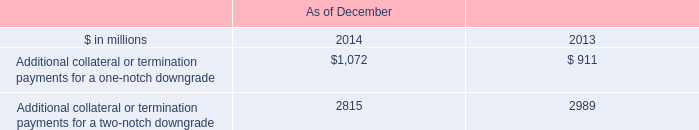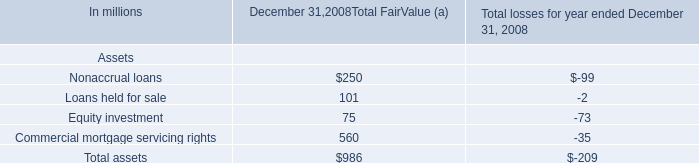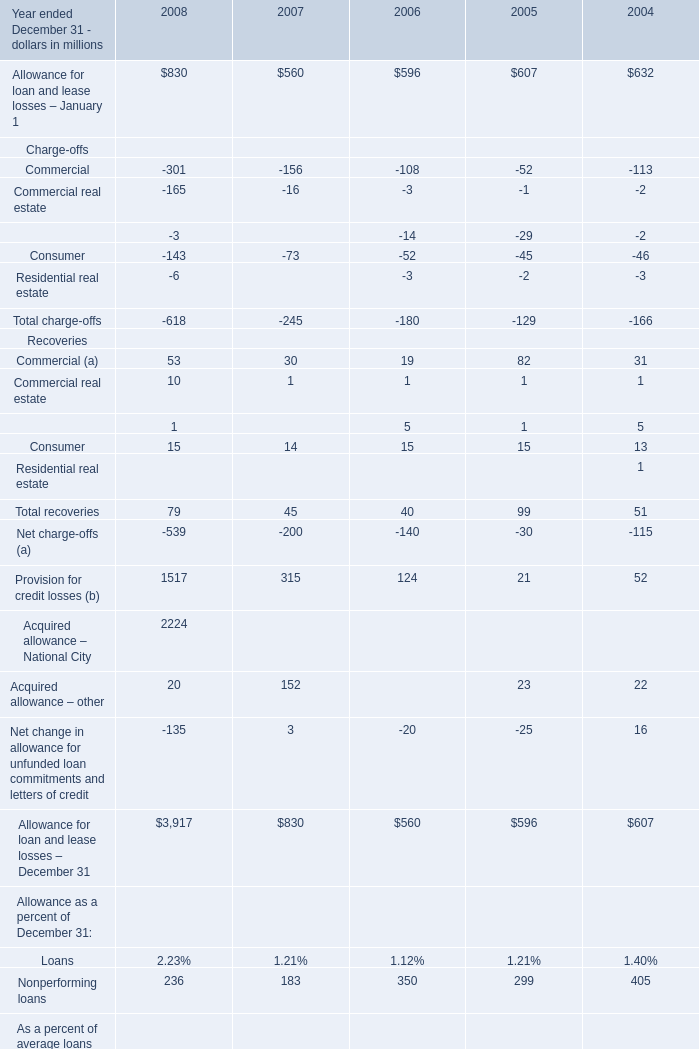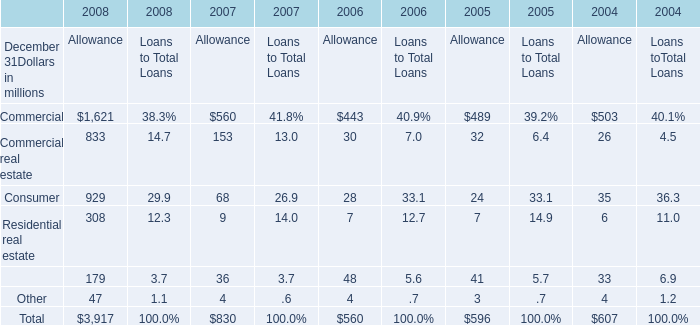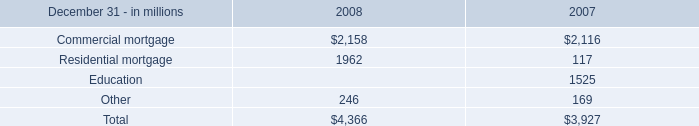If Commercial (a) develops with the same growth rate in 2008, what will it reach in 2009? (in million) 
Computations: ((((53 - 30) / 30) + 1) * 53)
Answer: 93.63333. 